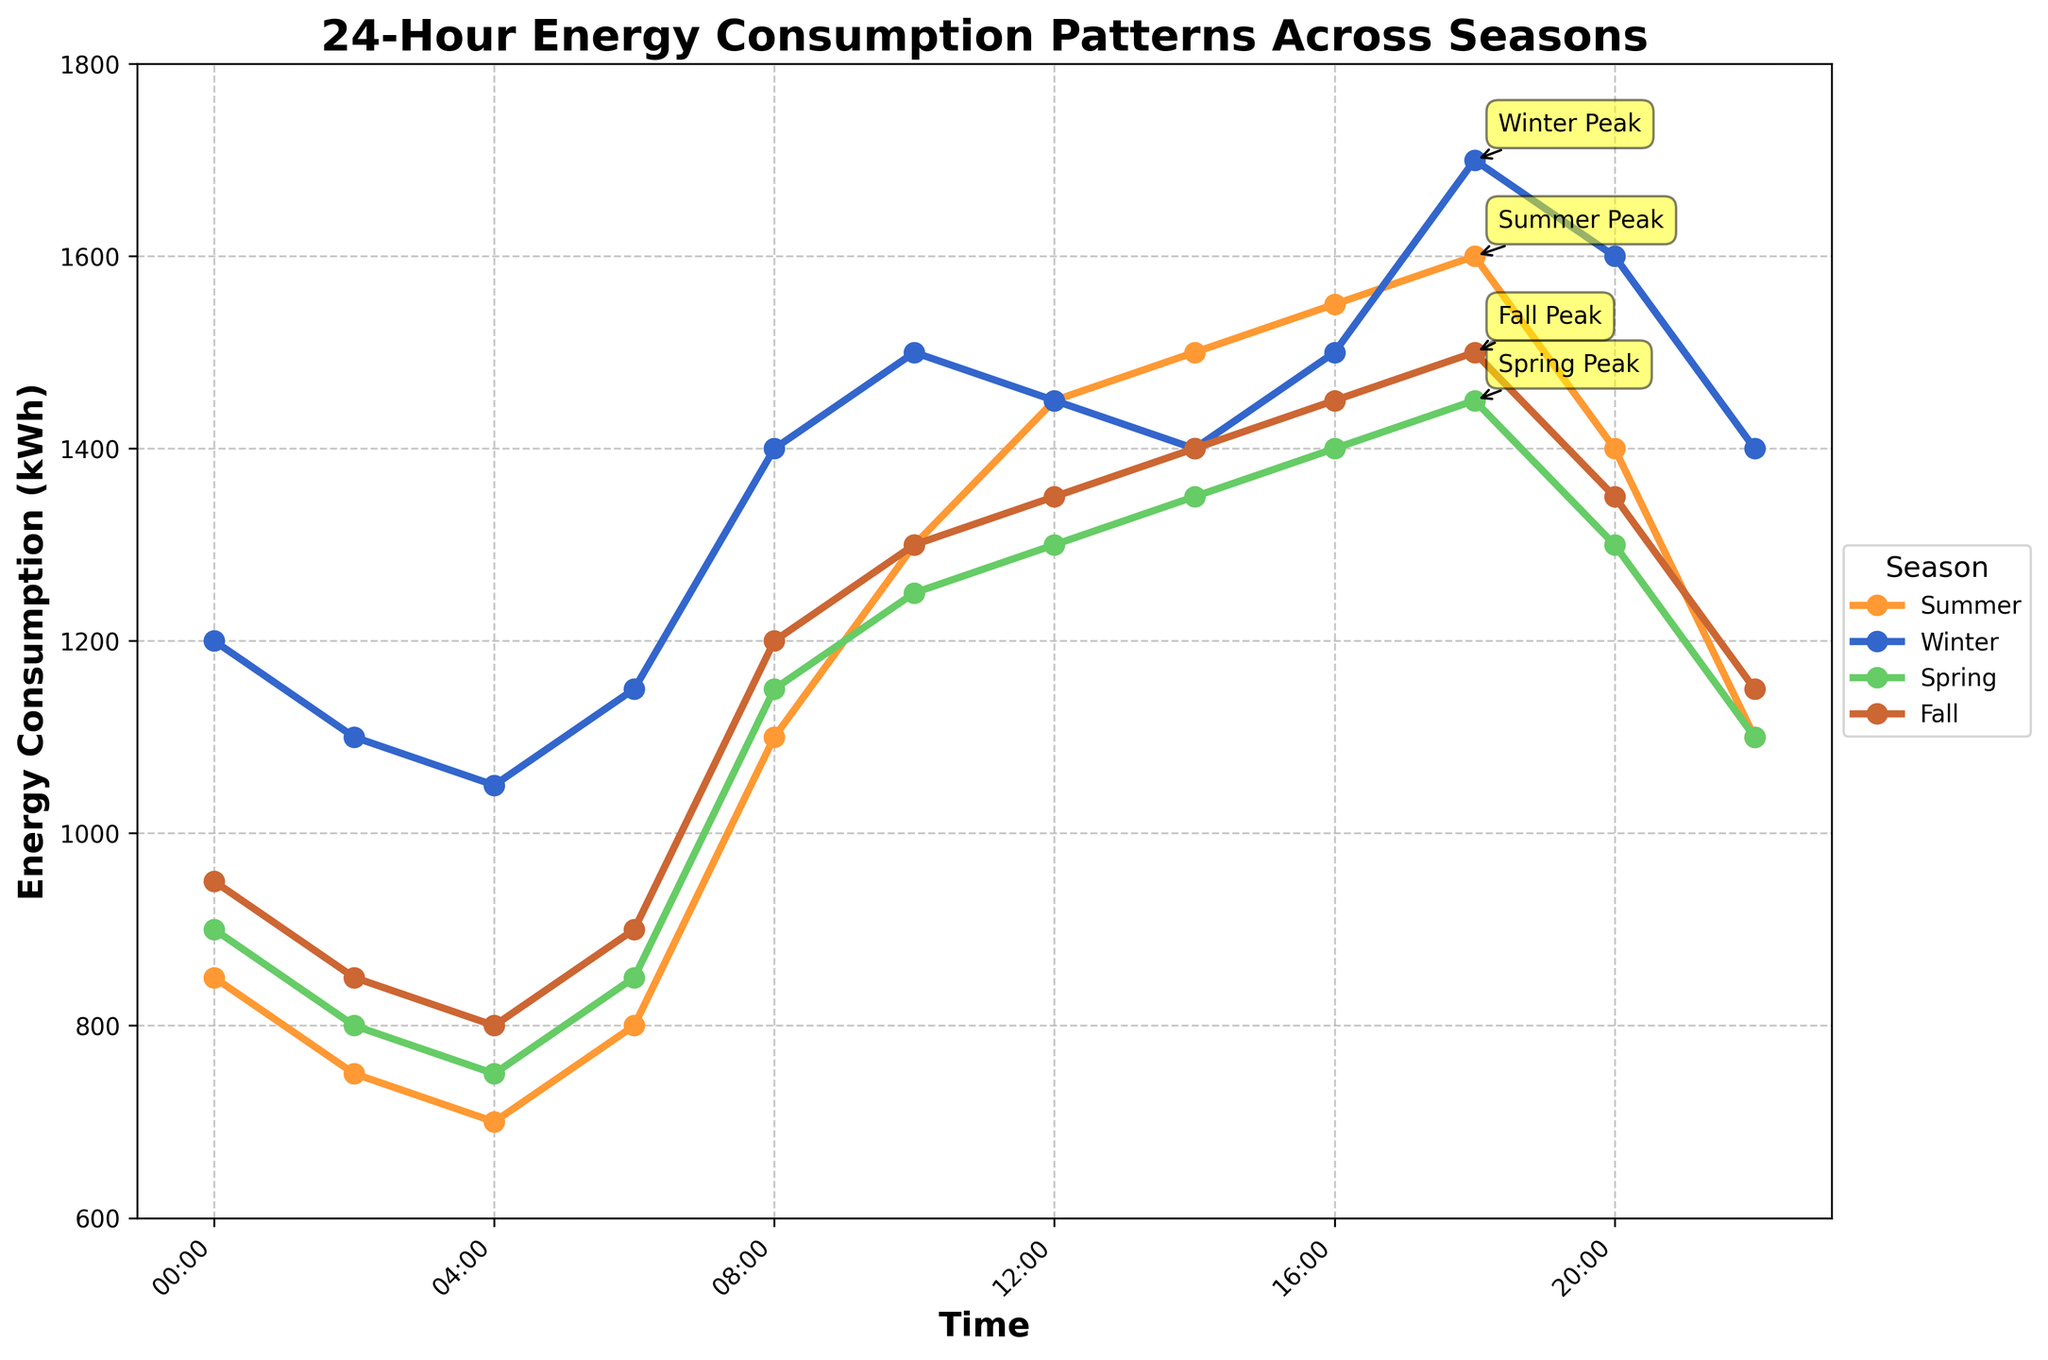Which season has the highest peak energy consumption? Look at the peak points marked for each season, and compare their values. The season with the highest value is the one with the highest peak energy consumption. Winter's peak at 18:00 is 1700 kWh, which is the highest.
Answer: Winter At what time does the energy consumption peak in Spring? Identify the peak point for Spring in the graph. The annotation indicates that the peak for Spring is at 18:00.
Answer: 18:00 Compare the energy consumption at 10:00 between Summer and Winter. Which one is higher? Check the energy consumption values at 10:00 for both Summer and Winter. Summer has 1300 kWh, and Winter has 1500 kWh. Winter’s value is higher.
Answer: Winter What is the total energy consumption from 06:00 to 12:00 in Fall? Look at the energy consumption values for Fall from 06:00 to 12:00 and sum them. The values are 900, 1200, 1300, and 1350 kWh. The total is 900 + 1200 + 1300 + 1350 = 4750 kWh.
Answer: 4750 kWh What is the difference in energy consumption between Summer and Spring at 22:00? Check the energy consumption values at 22:00 for Summer and Spring. Summer has 1100 kWh, and Spring has 1100 kWh. The difference is 1100 - 1100 = 0 kWh.
Answer: 0 kWh Which season has the lowest energy consumption at 04:00? Look at the energy consumption values at 04:00 for all seasons. Summer has 700 kWh, Winter has 1050 kWh, Spring has 750 kWh, and Fall has 800 kWh. Summer’s value is the lowest.
Answer: Summer What's the average energy consumption at 14:00 across all seasons? Look at the energy consumption values at 14:00 for all seasons. They are 1500, 1400, 1350, and 1400 kWh. Calculate the average: (1500 + 1400 + 1350 + 1400) / 4 = 1412.5 kWh.
Answer: 1412.5 kWh Is energy consumption at 08:00 in Summer higher or lower than at 18:00 in Spring? Check the values for Summer at 08:00 and Spring at 18:00. Summer has 1100 kWh, and Spring has 1450 kWh. Summer’s value is lower.
Answer: Lower Which two seasons show the smallest difference in energy consumption at 20:00? Compare the energy consumption at 20:00 for all pairs of seasons and find the pair with the smallest difference. The values are Summer: 1400, Winter: 1600, Spring: 1300, and Fall: 1350 kWh. The smallest difference is between Spring (1300) and Fall (1350): 1350 - 1300 = 50 kWh.
Answer: Spring and Fall 